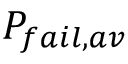<formula> <loc_0><loc_0><loc_500><loc_500>P _ { f a i l , a v }</formula> 